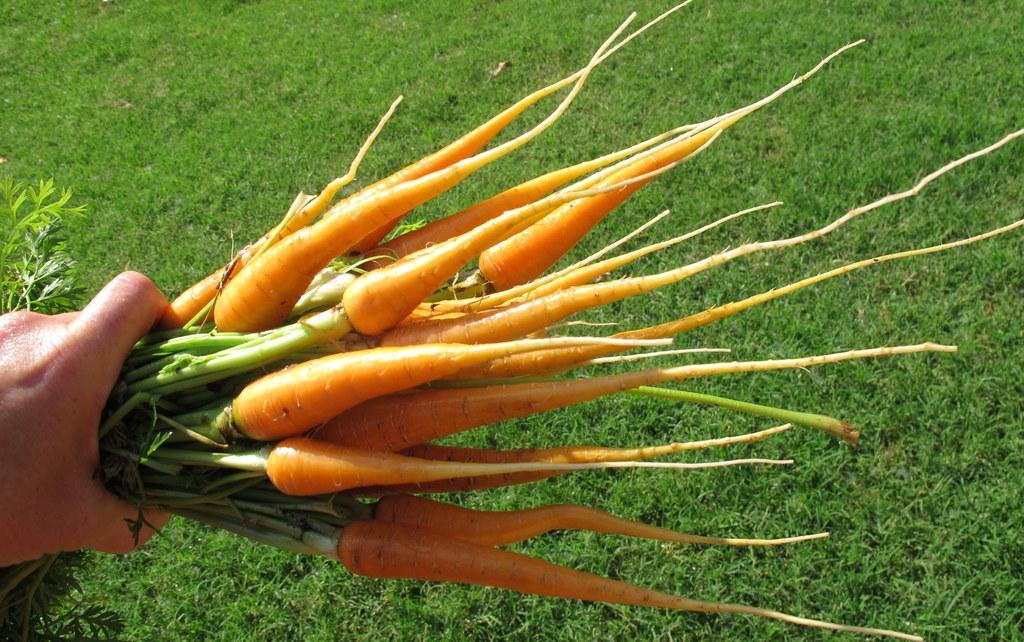Please provide a concise description of this image. In this picture we can see a person's hand who is holding the carrots. In the background we can see the farmland. On the right we can see the grass. 